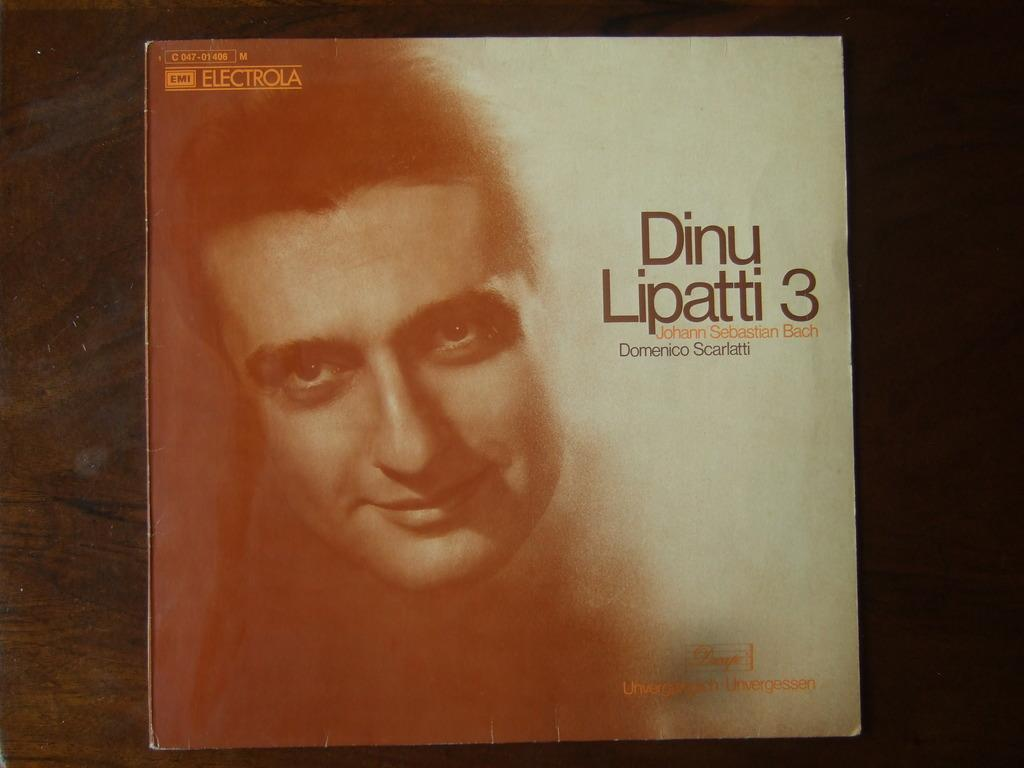What is the main subject of the image? The main subject of the image is a book cover. What can be seen on the book cover? There are words and an image of a person's face on the book cover. What type of minister is depicted on the book cover? There is no minister depicted on the book cover; it features words and an image of a person's face. 